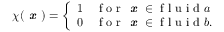<formula> <loc_0><loc_0><loc_500><loc_500>\chi ( \em x ) = \left \{ \begin{array} { l l } { 1 } & { f o r \em x \in f l u i d a } \\ { 0 } & { f o r \em x \in f l u i d b . } \end{array}</formula> 